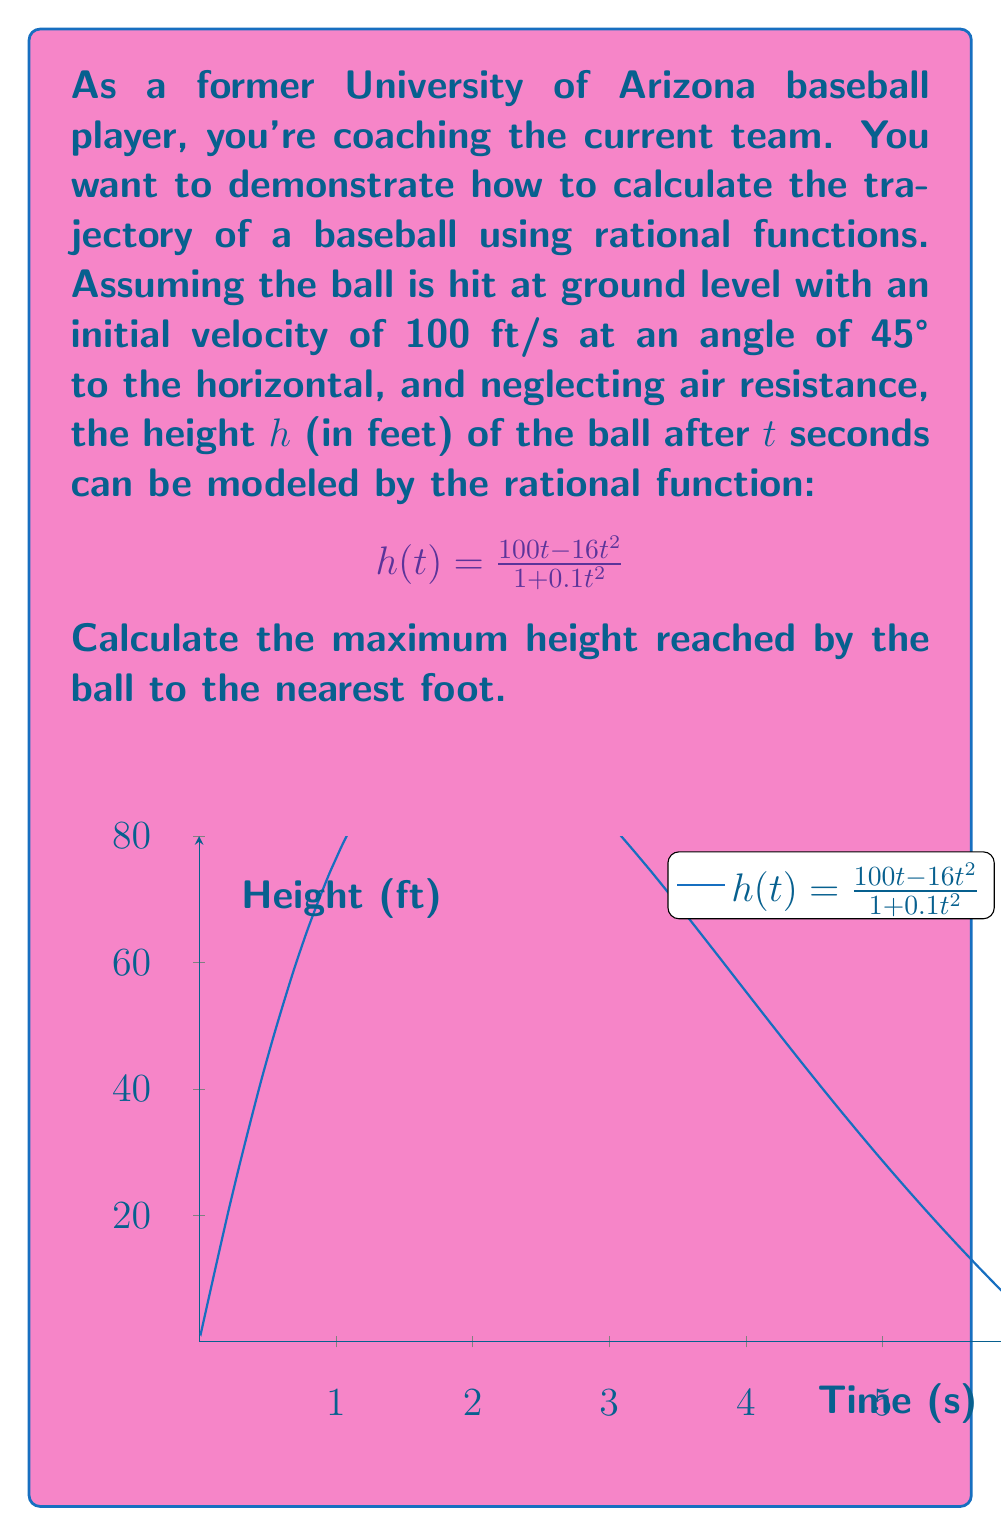Give your solution to this math problem. To find the maximum height, we need to follow these steps:

1) The maximum height occurs when the derivative of $h(t)$ equals zero. Let's find $h'(t)$:

   $$h'(t) = \frac{(100 - 32t)(1 + 0.1t^2) - (100t - 16t^2)(0.2t)}{(1 + 0.1t^2)^2}$$

2) Simplify the numerator:

   $$h'(t) = \frac{100 + 10t^2 - 32t - 3.2t^3 - 20t^2 + 3.2t^3}{(1 + 0.1t^2)^2}$$
   
   $$h'(t) = \frac{100 - 10t^2 - 32t}{(1 + 0.1t^2)^2}$$

3) Set $h'(t) = 0$ and solve for $t$:

   $$100 - 10t^2 - 32t = 0$$
   $$10t^2 + 32t - 100 = 0$$

4) This is a quadratic equation. Using the quadratic formula:

   $$t = \frac{-32 \pm \sqrt{32^2 + 4(10)(100)}}{2(10)}$$

   $$t = \frac{-32 \pm \sqrt{4024}}{20} \approx 2.27 \text{ or } -4.47$$

5) Since time can't be negative, $t \approx 2.27$ seconds.

6) Substitute this value back into the original function:

   $$h(2.27) = \frac{100(2.27) - 16(2.27)^2}{1 + 0.1(2.27)^2} \approx 78.43$$

7) Rounding to the nearest foot, the maximum height is 78 feet.
Answer: 78 feet 